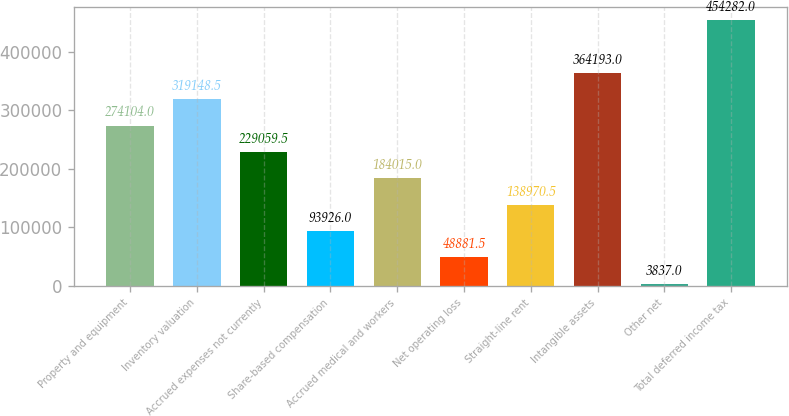<chart> <loc_0><loc_0><loc_500><loc_500><bar_chart><fcel>Property and equipment<fcel>Inventory valuation<fcel>Accrued expenses not currently<fcel>Share-based compensation<fcel>Accrued medical and workers<fcel>Net operating loss<fcel>Straight-line rent<fcel>Intangible assets<fcel>Other net<fcel>Total deferred income tax<nl><fcel>274104<fcel>319148<fcel>229060<fcel>93926<fcel>184015<fcel>48881.5<fcel>138970<fcel>364193<fcel>3837<fcel>454282<nl></chart> 